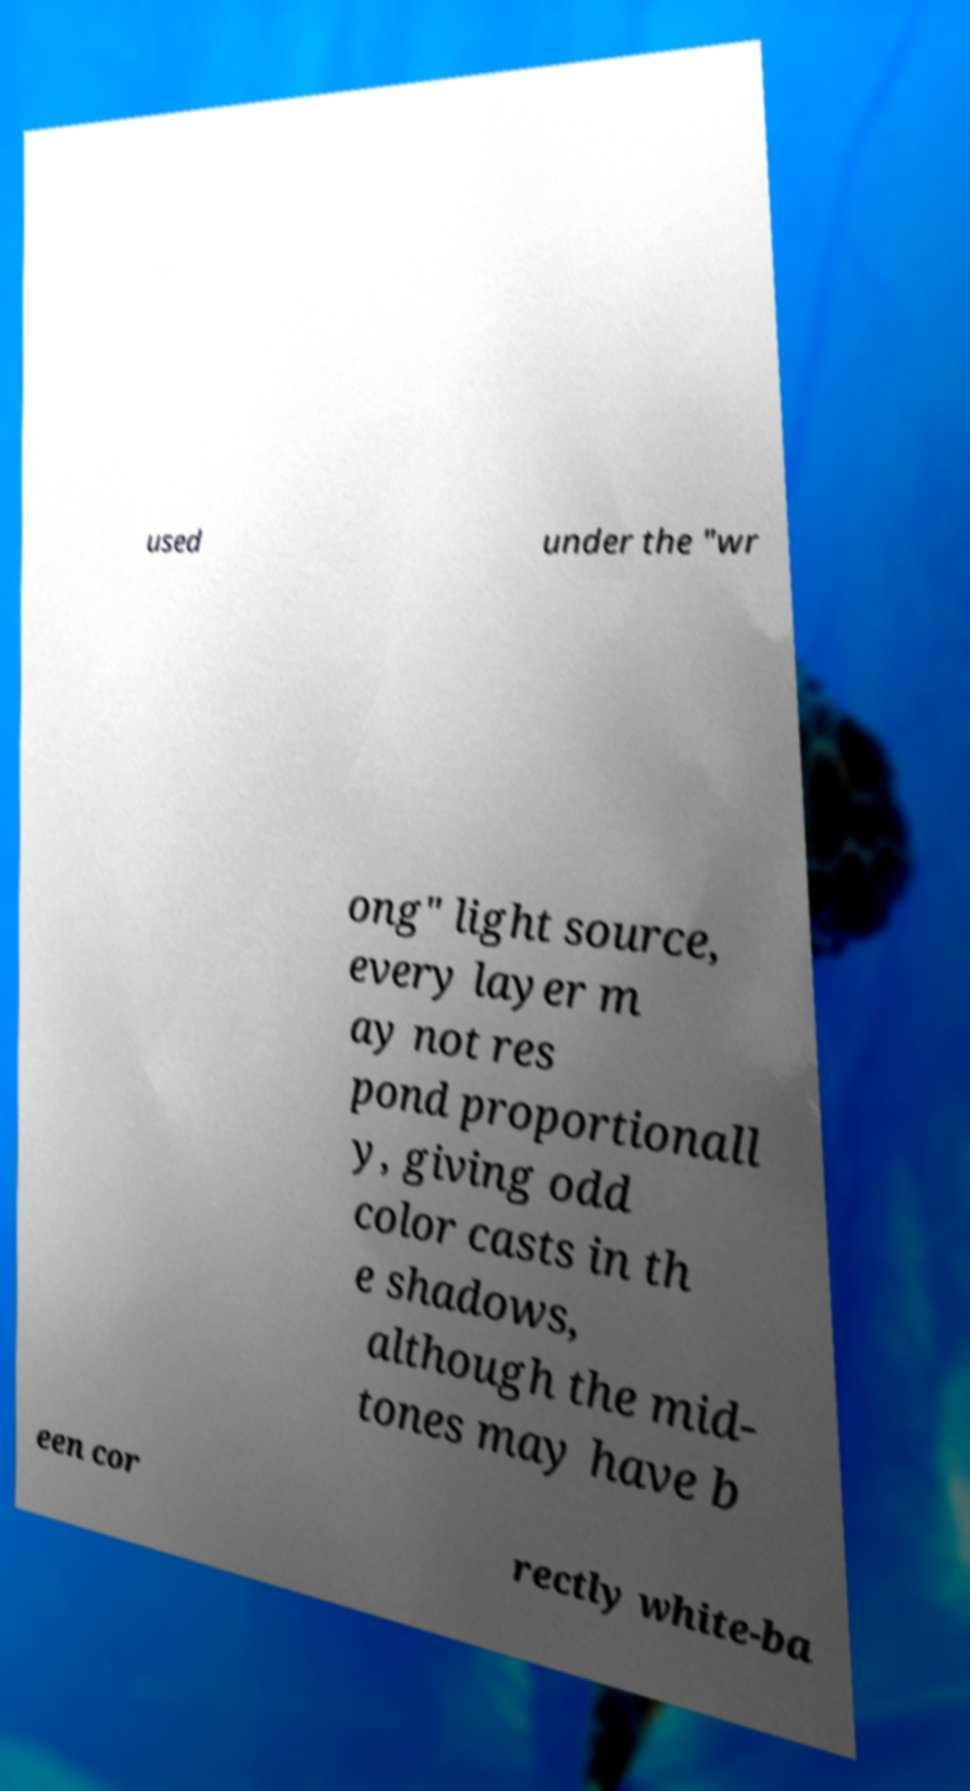Can you read and provide the text displayed in the image?This photo seems to have some interesting text. Can you extract and type it out for me? used under the "wr ong" light source, every layer m ay not res pond proportionall y, giving odd color casts in th e shadows, although the mid- tones may have b een cor rectly white-ba 